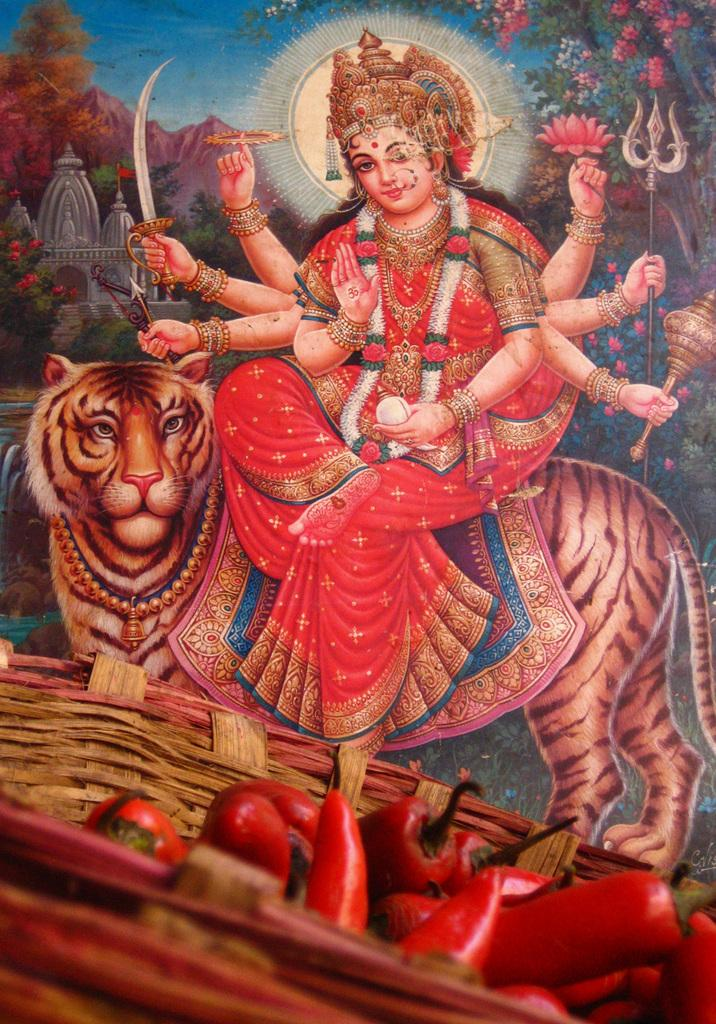What is the main subject of the image? There is a depiction of goddess Durga in the image. What is goddess Durga sitting on? Goddess Durga is sitting on a tiger. What is goddess Durga holding in the image? Goddess Durga is holding weapons. What can be seen in the image besides goddess Durga and the tiger? There is a basket in the image. What is inside the basket? The basket contains chilies. How long does it take for goddess Durga to sleep in the image? There is no indication of goddess Durga sleeping in the image, as she is depicted sitting on a tiger and holding weapons. What type of rail is present in the image? There is no rail present in the image; it features a depiction of goddess Durga sitting on a tiger and holding weapons, along with a basket containing chilies. 